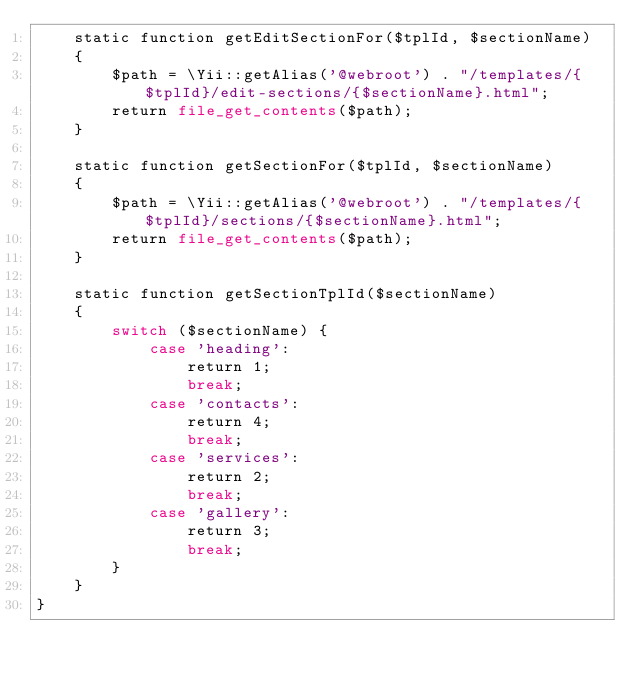<code> <loc_0><loc_0><loc_500><loc_500><_PHP_>    static function getEditSectionFor($tplId, $sectionName)
    {
        $path = \Yii::getAlias('@webroot') . "/templates/{$tplId}/edit-sections/{$sectionName}.html";
        return file_get_contents($path);
    }

    static function getSectionFor($tplId, $sectionName)
    {
        $path = \Yii::getAlias('@webroot') . "/templates/{$tplId}/sections/{$sectionName}.html";
        return file_get_contents($path);
    }

    static function getSectionTplId($sectionName)
    {
        switch ($sectionName) {
            case 'heading':
                return 1;
                break;
            case 'contacts':
                return 4;
                break;
            case 'services':
                return 2;
                break;
            case 'gallery':
                return 3;
                break;
        }
    }
}
</code> 